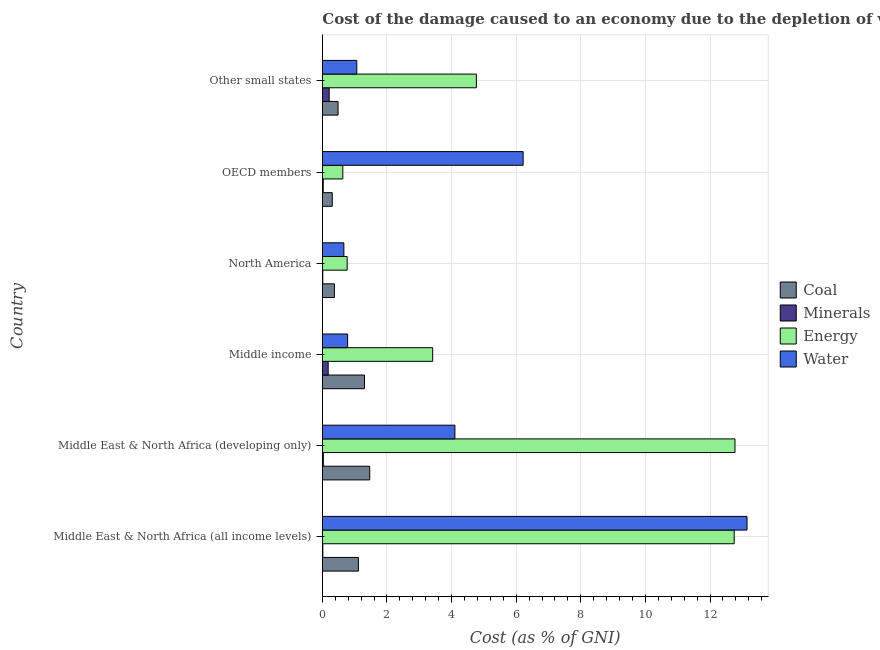How many different coloured bars are there?
Your response must be concise. 4. How many groups of bars are there?
Give a very brief answer. 6. Are the number of bars per tick equal to the number of legend labels?
Give a very brief answer. Yes. Are the number of bars on each tick of the Y-axis equal?
Offer a very short reply. Yes. How many bars are there on the 6th tick from the top?
Keep it short and to the point. 4. How many bars are there on the 3rd tick from the bottom?
Your answer should be compact. 4. What is the label of the 1st group of bars from the top?
Make the answer very short. Other small states. What is the cost of damage due to depletion of minerals in Other small states?
Make the answer very short. 0.21. Across all countries, what is the maximum cost of damage due to depletion of coal?
Your answer should be very brief. 1.47. Across all countries, what is the minimum cost of damage due to depletion of water?
Your response must be concise. 0.67. In which country was the cost of damage due to depletion of minerals maximum?
Your response must be concise. Other small states. What is the total cost of damage due to depletion of minerals in the graph?
Your response must be concise. 0.48. What is the difference between the cost of damage due to depletion of water in Middle income and that in OECD members?
Keep it short and to the point. -5.43. What is the difference between the cost of damage due to depletion of energy in OECD members and the cost of damage due to depletion of water in Middle East & North Africa (all income levels)?
Your answer should be very brief. -12.51. What is the average cost of damage due to depletion of coal per country?
Provide a succinct answer. 0.84. What is the difference between the cost of damage due to depletion of energy and cost of damage due to depletion of water in Middle East & North Africa (all income levels)?
Your answer should be very brief. -0.4. In how many countries, is the cost of damage due to depletion of water greater than 7.6 %?
Your answer should be very brief. 1. What is the ratio of the cost of damage due to depletion of minerals in Middle income to that in North America?
Ensure brevity in your answer.  12.58. Is the difference between the cost of damage due to depletion of water in Middle East & North Africa (developing only) and Other small states greater than the difference between the cost of damage due to depletion of coal in Middle East & North Africa (developing only) and Other small states?
Give a very brief answer. Yes. What is the difference between the highest and the second highest cost of damage due to depletion of coal?
Ensure brevity in your answer.  0.16. What is the difference between the highest and the lowest cost of damage due to depletion of coal?
Offer a terse response. 1.16. In how many countries, is the cost of damage due to depletion of coal greater than the average cost of damage due to depletion of coal taken over all countries?
Provide a succinct answer. 3. Is it the case that in every country, the sum of the cost of damage due to depletion of minerals and cost of damage due to depletion of water is greater than the sum of cost of damage due to depletion of coal and cost of damage due to depletion of energy?
Your response must be concise. No. What does the 1st bar from the top in OECD members represents?
Make the answer very short. Water. What does the 1st bar from the bottom in Middle East & North Africa (developing only) represents?
Provide a short and direct response. Coal. Is it the case that in every country, the sum of the cost of damage due to depletion of coal and cost of damage due to depletion of minerals is greater than the cost of damage due to depletion of energy?
Your answer should be very brief. No. How many countries are there in the graph?
Keep it short and to the point. 6. What is the difference between two consecutive major ticks on the X-axis?
Offer a terse response. 2. Does the graph contain any zero values?
Offer a terse response. No. What is the title of the graph?
Provide a short and direct response. Cost of the damage caused to an economy due to the depletion of various resources in 2003 . What is the label or title of the X-axis?
Your answer should be compact. Cost (as % of GNI). What is the label or title of the Y-axis?
Give a very brief answer. Country. What is the Cost (as % of GNI) of Coal in Middle East & North Africa (all income levels)?
Provide a succinct answer. 1.12. What is the Cost (as % of GNI) of Minerals in Middle East & North Africa (all income levels)?
Make the answer very short. 0.02. What is the Cost (as % of GNI) in Energy in Middle East & North Africa (all income levels)?
Offer a terse response. 12.75. What is the Cost (as % of GNI) in Water in Middle East & North Africa (all income levels)?
Your response must be concise. 13.15. What is the Cost (as % of GNI) in Coal in Middle East & North Africa (developing only)?
Your answer should be compact. 1.47. What is the Cost (as % of GNI) in Minerals in Middle East & North Africa (developing only)?
Give a very brief answer. 0.03. What is the Cost (as % of GNI) of Energy in Middle East & North Africa (developing only)?
Keep it short and to the point. 12.77. What is the Cost (as % of GNI) of Water in Middle East & North Africa (developing only)?
Make the answer very short. 4.1. What is the Cost (as % of GNI) in Coal in Middle income?
Make the answer very short. 1.31. What is the Cost (as % of GNI) in Minerals in Middle income?
Provide a succinct answer. 0.18. What is the Cost (as % of GNI) in Energy in Middle income?
Provide a succinct answer. 3.42. What is the Cost (as % of GNI) of Water in Middle income?
Offer a terse response. 0.78. What is the Cost (as % of GNI) of Coal in North America?
Make the answer very short. 0.37. What is the Cost (as % of GNI) of Minerals in North America?
Your answer should be very brief. 0.01. What is the Cost (as % of GNI) in Energy in North America?
Offer a terse response. 0.77. What is the Cost (as % of GNI) in Water in North America?
Give a very brief answer. 0.67. What is the Cost (as % of GNI) in Coal in OECD members?
Provide a short and direct response. 0.31. What is the Cost (as % of GNI) in Minerals in OECD members?
Provide a succinct answer. 0.03. What is the Cost (as % of GNI) of Energy in OECD members?
Your response must be concise. 0.63. What is the Cost (as % of GNI) of Water in OECD members?
Your answer should be compact. 6.22. What is the Cost (as % of GNI) in Coal in Other small states?
Ensure brevity in your answer.  0.49. What is the Cost (as % of GNI) of Minerals in Other small states?
Provide a succinct answer. 0.21. What is the Cost (as % of GNI) in Energy in Other small states?
Ensure brevity in your answer.  4.77. What is the Cost (as % of GNI) in Water in Other small states?
Your response must be concise. 1.07. Across all countries, what is the maximum Cost (as % of GNI) in Coal?
Provide a succinct answer. 1.47. Across all countries, what is the maximum Cost (as % of GNI) in Minerals?
Offer a terse response. 0.21. Across all countries, what is the maximum Cost (as % of GNI) in Energy?
Keep it short and to the point. 12.77. Across all countries, what is the maximum Cost (as % of GNI) of Water?
Your response must be concise. 13.15. Across all countries, what is the minimum Cost (as % of GNI) of Coal?
Provide a succinct answer. 0.31. Across all countries, what is the minimum Cost (as % of GNI) in Minerals?
Keep it short and to the point. 0.01. Across all countries, what is the minimum Cost (as % of GNI) of Energy?
Keep it short and to the point. 0.63. Across all countries, what is the minimum Cost (as % of GNI) of Water?
Make the answer very short. 0.67. What is the total Cost (as % of GNI) in Coal in the graph?
Give a very brief answer. 5.06. What is the total Cost (as % of GNI) of Minerals in the graph?
Provide a short and direct response. 0.48. What is the total Cost (as % of GNI) in Energy in the graph?
Your answer should be compact. 35.11. What is the total Cost (as % of GNI) in Water in the graph?
Offer a terse response. 25.98. What is the difference between the Cost (as % of GNI) in Coal in Middle East & North Africa (all income levels) and that in Middle East & North Africa (developing only)?
Ensure brevity in your answer.  -0.35. What is the difference between the Cost (as % of GNI) of Minerals in Middle East & North Africa (all income levels) and that in Middle East & North Africa (developing only)?
Offer a very short reply. -0.02. What is the difference between the Cost (as % of GNI) of Energy in Middle East & North Africa (all income levels) and that in Middle East & North Africa (developing only)?
Give a very brief answer. -0.02. What is the difference between the Cost (as % of GNI) in Water in Middle East & North Africa (all income levels) and that in Middle East & North Africa (developing only)?
Give a very brief answer. 9.04. What is the difference between the Cost (as % of GNI) of Coal in Middle East & North Africa (all income levels) and that in Middle income?
Make the answer very short. -0.19. What is the difference between the Cost (as % of GNI) in Minerals in Middle East & North Africa (all income levels) and that in Middle income?
Your answer should be compact. -0.17. What is the difference between the Cost (as % of GNI) of Energy in Middle East & North Africa (all income levels) and that in Middle income?
Your answer should be very brief. 9.33. What is the difference between the Cost (as % of GNI) of Water in Middle East & North Africa (all income levels) and that in Middle income?
Your response must be concise. 12.36. What is the difference between the Cost (as % of GNI) of Coal in Middle East & North Africa (all income levels) and that in North America?
Provide a succinct answer. 0.74. What is the difference between the Cost (as % of GNI) in Minerals in Middle East & North Africa (all income levels) and that in North America?
Provide a succinct answer. 0. What is the difference between the Cost (as % of GNI) in Energy in Middle East & North Africa (all income levels) and that in North America?
Your response must be concise. 11.98. What is the difference between the Cost (as % of GNI) in Water in Middle East & North Africa (all income levels) and that in North America?
Your answer should be compact. 12.48. What is the difference between the Cost (as % of GNI) of Coal in Middle East & North Africa (all income levels) and that in OECD members?
Give a very brief answer. 0.81. What is the difference between the Cost (as % of GNI) of Minerals in Middle East & North Africa (all income levels) and that in OECD members?
Your answer should be compact. -0.01. What is the difference between the Cost (as % of GNI) of Energy in Middle East & North Africa (all income levels) and that in OECD members?
Keep it short and to the point. 12.11. What is the difference between the Cost (as % of GNI) in Water in Middle East & North Africa (all income levels) and that in OECD members?
Provide a short and direct response. 6.93. What is the difference between the Cost (as % of GNI) in Coal in Middle East & North Africa (all income levels) and that in Other small states?
Keep it short and to the point. 0.63. What is the difference between the Cost (as % of GNI) in Minerals in Middle East & North Africa (all income levels) and that in Other small states?
Ensure brevity in your answer.  -0.2. What is the difference between the Cost (as % of GNI) in Energy in Middle East & North Africa (all income levels) and that in Other small states?
Ensure brevity in your answer.  7.98. What is the difference between the Cost (as % of GNI) in Water in Middle East & North Africa (all income levels) and that in Other small states?
Your answer should be very brief. 12.08. What is the difference between the Cost (as % of GNI) in Coal in Middle East & North Africa (developing only) and that in Middle income?
Your answer should be compact. 0.16. What is the difference between the Cost (as % of GNI) of Minerals in Middle East & North Africa (developing only) and that in Middle income?
Your answer should be very brief. -0.15. What is the difference between the Cost (as % of GNI) in Energy in Middle East & North Africa (developing only) and that in Middle income?
Make the answer very short. 9.36. What is the difference between the Cost (as % of GNI) in Water in Middle East & North Africa (developing only) and that in Middle income?
Provide a short and direct response. 3.32. What is the difference between the Cost (as % of GNI) of Coal in Middle East & North Africa (developing only) and that in North America?
Provide a short and direct response. 1.09. What is the difference between the Cost (as % of GNI) of Minerals in Middle East & North Africa (developing only) and that in North America?
Give a very brief answer. 0.02. What is the difference between the Cost (as % of GNI) in Energy in Middle East & North Africa (developing only) and that in North America?
Make the answer very short. 12. What is the difference between the Cost (as % of GNI) in Water in Middle East & North Africa (developing only) and that in North America?
Offer a very short reply. 3.44. What is the difference between the Cost (as % of GNI) of Coal in Middle East & North Africa (developing only) and that in OECD members?
Provide a short and direct response. 1.16. What is the difference between the Cost (as % of GNI) in Minerals in Middle East & North Africa (developing only) and that in OECD members?
Your response must be concise. 0. What is the difference between the Cost (as % of GNI) in Energy in Middle East & North Africa (developing only) and that in OECD members?
Ensure brevity in your answer.  12.14. What is the difference between the Cost (as % of GNI) in Water in Middle East & North Africa (developing only) and that in OECD members?
Give a very brief answer. -2.11. What is the difference between the Cost (as % of GNI) of Coal in Middle East & North Africa (developing only) and that in Other small states?
Your answer should be very brief. 0.98. What is the difference between the Cost (as % of GNI) of Minerals in Middle East & North Africa (developing only) and that in Other small states?
Ensure brevity in your answer.  -0.18. What is the difference between the Cost (as % of GNI) of Energy in Middle East & North Africa (developing only) and that in Other small states?
Offer a terse response. 8.01. What is the difference between the Cost (as % of GNI) in Water in Middle East & North Africa (developing only) and that in Other small states?
Your answer should be compact. 3.04. What is the difference between the Cost (as % of GNI) of Coal in Middle income and that in North America?
Your response must be concise. 0.93. What is the difference between the Cost (as % of GNI) of Minerals in Middle income and that in North America?
Provide a succinct answer. 0.17. What is the difference between the Cost (as % of GNI) in Energy in Middle income and that in North America?
Give a very brief answer. 2.65. What is the difference between the Cost (as % of GNI) of Water in Middle income and that in North America?
Offer a very short reply. 0.12. What is the difference between the Cost (as % of GNI) in Minerals in Middle income and that in OECD members?
Your answer should be compact. 0.15. What is the difference between the Cost (as % of GNI) in Energy in Middle income and that in OECD members?
Make the answer very short. 2.78. What is the difference between the Cost (as % of GNI) in Water in Middle income and that in OECD members?
Your answer should be compact. -5.43. What is the difference between the Cost (as % of GNI) in Coal in Middle income and that in Other small states?
Offer a very short reply. 0.82. What is the difference between the Cost (as % of GNI) in Minerals in Middle income and that in Other small states?
Ensure brevity in your answer.  -0.03. What is the difference between the Cost (as % of GNI) in Energy in Middle income and that in Other small states?
Make the answer very short. -1.35. What is the difference between the Cost (as % of GNI) of Water in Middle income and that in Other small states?
Your answer should be very brief. -0.28. What is the difference between the Cost (as % of GNI) in Coal in North America and that in OECD members?
Offer a terse response. 0.07. What is the difference between the Cost (as % of GNI) in Minerals in North America and that in OECD members?
Make the answer very short. -0.01. What is the difference between the Cost (as % of GNI) of Energy in North America and that in OECD members?
Provide a succinct answer. 0.13. What is the difference between the Cost (as % of GNI) in Water in North America and that in OECD members?
Make the answer very short. -5.55. What is the difference between the Cost (as % of GNI) of Coal in North America and that in Other small states?
Your answer should be compact. -0.11. What is the difference between the Cost (as % of GNI) in Minerals in North America and that in Other small states?
Offer a very short reply. -0.2. What is the difference between the Cost (as % of GNI) in Energy in North America and that in Other small states?
Offer a terse response. -4. What is the difference between the Cost (as % of GNI) in Water in North America and that in Other small states?
Give a very brief answer. -0.4. What is the difference between the Cost (as % of GNI) of Coal in OECD members and that in Other small states?
Provide a short and direct response. -0.18. What is the difference between the Cost (as % of GNI) in Minerals in OECD members and that in Other small states?
Make the answer very short. -0.18. What is the difference between the Cost (as % of GNI) in Energy in OECD members and that in Other small states?
Your answer should be very brief. -4.13. What is the difference between the Cost (as % of GNI) in Water in OECD members and that in Other small states?
Your answer should be very brief. 5.15. What is the difference between the Cost (as % of GNI) of Coal in Middle East & North Africa (all income levels) and the Cost (as % of GNI) of Minerals in Middle East & North Africa (developing only)?
Provide a succinct answer. 1.09. What is the difference between the Cost (as % of GNI) in Coal in Middle East & North Africa (all income levels) and the Cost (as % of GNI) in Energy in Middle East & North Africa (developing only)?
Your response must be concise. -11.66. What is the difference between the Cost (as % of GNI) of Coal in Middle East & North Africa (all income levels) and the Cost (as % of GNI) of Water in Middle East & North Africa (developing only)?
Provide a succinct answer. -2.99. What is the difference between the Cost (as % of GNI) in Minerals in Middle East & North Africa (all income levels) and the Cost (as % of GNI) in Energy in Middle East & North Africa (developing only)?
Offer a very short reply. -12.76. What is the difference between the Cost (as % of GNI) of Minerals in Middle East & North Africa (all income levels) and the Cost (as % of GNI) of Water in Middle East & North Africa (developing only)?
Provide a short and direct response. -4.09. What is the difference between the Cost (as % of GNI) in Energy in Middle East & North Africa (all income levels) and the Cost (as % of GNI) in Water in Middle East & North Africa (developing only)?
Keep it short and to the point. 8.65. What is the difference between the Cost (as % of GNI) of Coal in Middle East & North Africa (all income levels) and the Cost (as % of GNI) of Minerals in Middle income?
Your answer should be compact. 0.94. What is the difference between the Cost (as % of GNI) of Coal in Middle East & North Africa (all income levels) and the Cost (as % of GNI) of Energy in Middle income?
Keep it short and to the point. -2.3. What is the difference between the Cost (as % of GNI) of Coal in Middle East & North Africa (all income levels) and the Cost (as % of GNI) of Water in Middle income?
Provide a short and direct response. 0.33. What is the difference between the Cost (as % of GNI) of Minerals in Middle East & North Africa (all income levels) and the Cost (as % of GNI) of Energy in Middle income?
Provide a succinct answer. -3.4. What is the difference between the Cost (as % of GNI) in Minerals in Middle East & North Africa (all income levels) and the Cost (as % of GNI) in Water in Middle income?
Give a very brief answer. -0.77. What is the difference between the Cost (as % of GNI) in Energy in Middle East & North Africa (all income levels) and the Cost (as % of GNI) in Water in Middle income?
Ensure brevity in your answer.  11.97. What is the difference between the Cost (as % of GNI) of Coal in Middle East & North Africa (all income levels) and the Cost (as % of GNI) of Minerals in North America?
Keep it short and to the point. 1.1. What is the difference between the Cost (as % of GNI) of Coal in Middle East & North Africa (all income levels) and the Cost (as % of GNI) of Energy in North America?
Offer a very short reply. 0.35. What is the difference between the Cost (as % of GNI) of Coal in Middle East & North Africa (all income levels) and the Cost (as % of GNI) of Water in North America?
Keep it short and to the point. 0.45. What is the difference between the Cost (as % of GNI) of Minerals in Middle East & North Africa (all income levels) and the Cost (as % of GNI) of Energy in North America?
Your response must be concise. -0.75. What is the difference between the Cost (as % of GNI) in Minerals in Middle East & North Africa (all income levels) and the Cost (as % of GNI) in Water in North America?
Keep it short and to the point. -0.65. What is the difference between the Cost (as % of GNI) in Energy in Middle East & North Africa (all income levels) and the Cost (as % of GNI) in Water in North America?
Your answer should be very brief. 12.08. What is the difference between the Cost (as % of GNI) of Coal in Middle East & North Africa (all income levels) and the Cost (as % of GNI) of Minerals in OECD members?
Keep it short and to the point. 1.09. What is the difference between the Cost (as % of GNI) of Coal in Middle East & North Africa (all income levels) and the Cost (as % of GNI) of Energy in OECD members?
Your answer should be compact. 0.48. What is the difference between the Cost (as % of GNI) in Coal in Middle East & North Africa (all income levels) and the Cost (as % of GNI) in Water in OECD members?
Your response must be concise. -5.1. What is the difference between the Cost (as % of GNI) in Minerals in Middle East & North Africa (all income levels) and the Cost (as % of GNI) in Energy in OECD members?
Make the answer very short. -0.62. What is the difference between the Cost (as % of GNI) in Minerals in Middle East & North Africa (all income levels) and the Cost (as % of GNI) in Water in OECD members?
Your answer should be compact. -6.2. What is the difference between the Cost (as % of GNI) in Energy in Middle East & North Africa (all income levels) and the Cost (as % of GNI) in Water in OECD members?
Offer a terse response. 6.53. What is the difference between the Cost (as % of GNI) of Coal in Middle East & North Africa (all income levels) and the Cost (as % of GNI) of Minerals in Other small states?
Offer a terse response. 0.91. What is the difference between the Cost (as % of GNI) of Coal in Middle East & North Africa (all income levels) and the Cost (as % of GNI) of Energy in Other small states?
Provide a short and direct response. -3.65. What is the difference between the Cost (as % of GNI) of Coal in Middle East & North Africa (all income levels) and the Cost (as % of GNI) of Water in Other small states?
Offer a terse response. 0.05. What is the difference between the Cost (as % of GNI) of Minerals in Middle East & North Africa (all income levels) and the Cost (as % of GNI) of Energy in Other small states?
Your answer should be very brief. -4.75. What is the difference between the Cost (as % of GNI) of Minerals in Middle East & North Africa (all income levels) and the Cost (as % of GNI) of Water in Other small states?
Provide a succinct answer. -1.05. What is the difference between the Cost (as % of GNI) in Energy in Middle East & North Africa (all income levels) and the Cost (as % of GNI) in Water in Other small states?
Provide a succinct answer. 11.68. What is the difference between the Cost (as % of GNI) in Coal in Middle East & North Africa (developing only) and the Cost (as % of GNI) in Minerals in Middle income?
Offer a very short reply. 1.28. What is the difference between the Cost (as % of GNI) of Coal in Middle East & North Africa (developing only) and the Cost (as % of GNI) of Energy in Middle income?
Your answer should be very brief. -1.95. What is the difference between the Cost (as % of GNI) of Coal in Middle East & North Africa (developing only) and the Cost (as % of GNI) of Water in Middle income?
Provide a short and direct response. 0.68. What is the difference between the Cost (as % of GNI) of Minerals in Middle East & North Africa (developing only) and the Cost (as % of GNI) of Energy in Middle income?
Provide a short and direct response. -3.39. What is the difference between the Cost (as % of GNI) of Minerals in Middle East & North Africa (developing only) and the Cost (as % of GNI) of Water in Middle income?
Provide a succinct answer. -0.75. What is the difference between the Cost (as % of GNI) of Energy in Middle East & North Africa (developing only) and the Cost (as % of GNI) of Water in Middle income?
Provide a succinct answer. 11.99. What is the difference between the Cost (as % of GNI) of Coal in Middle East & North Africa (developing only) and the Cost (as % of GNI) of Minerals in North America?
Your answer should be very brief. 1.45. What is the difference between the Cost (as % of GNI) of Coal in Middle East & North Africa (developing only) and the Cost (as % of GNI) of Energy in North America?
Ensure brevity in your answer.  0.7. What is the difference between the Cost (as % of GNI) in Coal in Middle East & North Africa (developing only) and the Cost (as % of GNI) in Water in North America?
Your answer should be compact. 0.8. What is the difference between the Cost (as % of GNI) of Minerals in Middle East & North Africa (developing only) and the Cost (as % of GNI) of Energy in North America?
Provide a succinct answer. -0.74. What is the difference between the Cost (as % of GNI) of Minerals in Middle East & North Africa (developing only) and the Cost (as % of GNI) of Water in North America?
Your answer should be very brief. -0.64. What is the difference between the Cost (as % of GNI) in Energy in Middle East & North Africa (developing only) and the Cost (as % of GNI) in Water in North America?
Your answer should be compact. 12.11. What is the difference between the Cost (as % of GNI) of Coal in Middle East & North Africa (developing only) and the Cost (as % of GNI) of Minerals in OECD members?
Keep it short and to the point. 1.44. What is the difference between the Cost (as % of GNI) of Coal in Middle East & North Africa (developing only) and the Cost (as % of GNI) of Energy in OECD members?
Ensure brevity in your answer.  0.83. What is the difference between the Cost (as % of GNI) of Coal in Middle East & North Africa (developing only) and the Cost (as % of GNI) of Water in OECD members?
Your answer should be compact. -4.75. What is the difference between the Cost (as % of GNI) in Minerals in Middle East & North Africa (developing only) and the Cost (as % of GNI) in Energy in OECD members?
Give a very brief answer. -0.6. What is the difference between the Cost (as % of GNI) in Minerals in Middle East & North Africa (developing only) and the Cost (as % of GNI) in Water in OECD members?
Offer a very short reply. -6.18. What is the difference between the Cost (as % of GNI) in Energy in Middle East & North Africa (developing only) and the Cost (as % of GNI) in Water in OECD members?
Keep it short and to the point. 6.56. What is the difference between the Cost (as % of GNI) of Coal in Middle East & North Africa (developing only) and the Cost (as % of GNI) of Minerals in Other small states?
Your answer should be compact. 1.25. What is the difference between the Cost (as % of GNI) in Coal in Middle East & North Africa (developing only) and the Cost (as % of GNI) in Energy in Other small states?
Give a very brief answer. -3.3. What is the difference between the Cost (as % of GNI) of Coal in Middle East & North Africa (developing only) and the Cost (as % of GNI) of Water in Other small states?
Make the answer very short. 0.4. What is the difference between the Cost (as % of GNI) of Minerals in Middle East & North Africa (developing only) and the Cost (as % of GNI) of Energy in Other small states?
Offer a terse response. -4.74. What is the difference between the Cost (as % of GNI) in Minerals in Middle East & North Africa (developing only) and the Cost (as % of GNI) in Water in Other small states?
Make the answer very short. -1.04. What is the difference between the Cost (as % of GNI) in Energy in Middle East & North Africa (developing only) and the Cost (as % of GNI) in Water in Other small states?
Provide a short and direct response. 11.71. What is the difference between the Cost (as % of GNI) of Coal in Middle income and the Cost (as % of GNI) of Minerals in North America?
Give a very brief answer. 1.29. What is the difference between the Cost (as % of GNI) in Coal in Middle income and the Cost (as % of GNI) in Energy in North America?
Offer a terse response. 0.54. What is the difference between the Cost (as % of GNI) in Coal in Middle income and the Cost (as % of GNI) in Water in North America?
Provide a short and direct response. 0.64. What is the difference between the Cost (as % of GNI) of Minerals in Middle income and the Cost (as % of GNI) of Energy in North America?
Your response must be concise. -0.59. What is the difference between the Cost (as % of GNI) of Minerals in Middle income and the Cost (as % of GNI) of Water in North America?
Offer a terse response. -0.49. What is the difference between the Cost (as % of GNI) in Energy in Middle income and the Cost (as % of GNI) in Water in North America?
Make the answer very short. 2.75. What is the difference between the Cost (as % of GNI) of Coal in Middle income and the Cost (as % of GNI) of Minerals in OECD members?
Offer a very short reply. 1.28. What is the difference between the Cost (as % of GNI) in Coal in Middle income and the Cost (as % of GNI) in Energy in OECD members?
Offer a very short reply. 0.67. What is the difference between the Cost (as % of GNI) in Coal in Middle income and the Cost (as % of GNI) in Water in OECD members?
Your answer should be compact. -4.91. What is the difference between the Cost (as % of GNI) of Minerals in Middle income and the Cost (as % of GNI) of Energy in OECD members?
Your answer should be compact. -0.45. What is the difference between the Cost (as % of GNI) in Minerals in Middle income and the Cost (as % of GNI) in Water in OECD members?
Your response must be concise. -6.03. What is the difference between the Cost (as % of GNI) of Energy in Middle income and the Cost (as % of GNI) of Water in OECD members?
Your answer should be compact. -2.8. What is the difference between the Cost (as % of GNI) in Coal in Middle income and the Cost (as % of GNI) in Minerals in Other small states?
Offer a very short reply. 1.09. What is the difference between the Cost (as % of GNI) of Coal in Middle income and the Cost (as % of GNI) of Energy in Other small states?
Offer a very short reply. -3.46. What is the difference between the Cost (as % of GNI) in Coal in Middle income and the Cost (as % of GNI) in Water in Other small states?
Your response must be concise. 0.24. What is the difference between the Cost (as % of GNI) in Minerals in Middle income and the Cost (as % of GNI) in Energy in Other small states?
Your response must be concise. -4.59. What is the difference between the Cost (as % of GNI) of Minerals in Middle income and the Cost (as % of GNI) of Water in Other small states?
Your response must be concise. -0.89. What is the difference between the Cost (as % of GNI) in Energy in Middle income and the Cost (as % of GNI) in Water in Other small states?
Offer a terse response. 2.35. What is the difference between the Cost (as % of GNI) in Coal in North America and the Cost (as % of GNI) in Minerals in OECD members?
Make the answer very short. 0.35. What is the difference between the Cost (as % of GNI) in Coal in North America and the Cost (as % of GNI) in Energy in OECD members?
Your answer should be compact. -0.26. What is the difference between the Cost (as % of GNI) of Coal in North America and the Cost (as % of GNI) of Water in OECD members?
Offer a very short reply. -5.84. What is the difference between the Cost (as % of GNI) of Minerals in North America and the Cost (as % of GNI) of Energy in OECD members?
Provide a short and direct response. -0.62. What is the difference between the Cost (as % of GNI) of Minerals in North America and the Cost (as % of GNI) of Water in OECD members?
Give a very brief answer. -6.2. What is the difference between the Cost (as % of GNI) of Energy in North America and the Cost (as % of GNI) of Water in OECD members?
Your response must be concise. -5.45. What is the difference between the Cost (as % of GNI) of Coal in North America and the Cost (as % of GNI) of Minerals in Other small states?
Your answer should be very brief. 0.16. What is the difference between the Cost (as % of GNI) in Coal in North America and the Cost (as % of GNI) in Energy in Other small states?
Give a very brief answer. -4.39. What is the difference between the Cost (as % of GNI) of Coal in North America and the Cost (as % of GNI) of Water in Other small states?
Your answer should be compact. -0.69. What is the difference between the Cost (as % of GNI) in Minerals in North America and the Cost (as % of GNI) in Energy in Other small states?
Provide a succinct answer. -4.75. What is the difference between the Cost (as % of GNI) of Minerals in North America and the Cost (as % of GNI) of Water in Other small states?
Provide a short and direct response. -1.05. What is the difference between the Cost (as % of GNI) of Energy in North America and the Cost (as % of GNI) of Water in Other small states?
Provide a short and direct response. -0.3. What is the difference between the Cost (as % of GNI) of Coal in OECD members and the Cost (as % of GNI) of Minerals in Other small states?
Your response must be concise. 0.1. What is the difference between the Cost (as % of GNI) of Coal in OECD members and the Cost (as % of GNI) of Energy in Other small states?
Offer a terse response. -4.46. What is the difference between the Cost (as % of GNI) of Coal in OECD members and the Cost (as % of GNI) of Water in Other small states?
Provide a short and direct response. -0.76. What is the difference between the Cost (as % of GNI) in Minerals in OECD members and the Cost (as % of GNI) in Energy in Other small states?
Provide a short and direct response. -4.74. What is the difference between the Cost (as % of GNI) of Minerals in OECD members and the Cost (as % of GNI) of Water in Other small states?
Provide a short and direct response. -1.04. What is the difference between the Cost (as % of GNI) of Energy in OECD members and the Cost (as % of GNI) of Water in Other small states?
Your response must be concise. -0.43. What is the average Cost (as % of GNI) in Coal per country?
Provide a succinct answer. 0.84. What is the average Cost (as % of GNI) of Minerals per country?
Provide a short and direct response. 0.08. What is the average Cost (as % of GNI) in Energy per country?
Your answer should be very brief. 5.85. What is the average Cost (as % of GNI) of Water per country?
Provide a succinct answer. 4.33. What is the difference between the Cost (as % of GNI) of Coal and Cost (as % of GNI) of Minerals in Middle East & North Africa (all income levels)?
Offer a terse response. 1.1. What is the difference between the Cost (as % of GNI) of Coal and Cost (as % of GNI) of Energy in Middle East & North Africa (all income levels)?
Provide a succinct answer. -11.63. What is the difference between the Cost (as % of GNI) in Coal and Cost (as % of GNI) in Water in Middle East & North Africa (all income levels)?
Give a very brief answer. -12.03. What is the difference between the Cost (as % of GNI) in Minerals and Cost (as % of GNI) in Energy in Middle East & North Africa (all income levels)?
Make the answer very short. -12.73. What is the difference between the Cost (as % of GNI) of Minerals and Cost (as % of GNI) of Water in Middle East & North Africa (all income levels)?
Make the answer very short. -13.13. What is the difference between the Cost (as % of GNI) of Energy and Cost (as % of GNI) of Water in Middle East & North Africa (all income levels)?
Provide a succinct answer. -0.4. What is the difference between the Cost (as % of GNI) in Coal and Cost (as % of GNI) in Minerals in Middle East & North Africa (developing only)?
Offer a very short reply. 1.44. What is the difference between the Cost (as % of GNI) of Coal and Cost (as % of GNI) of Energy in Middle East & North Africa (developing only)?
Offer a very short reply. -11.31. What is the difference between the Cost (as % of GNI) in Coal and Cost (as % of GNI) in Water in Middle East & North Africa (developing only)?
Provide a succinct answer. -2.64. What is the difference between the Cost (as % of GNI) in Minerals and Cost (as % of GNI) in Energy in Middle East & North Africa (developing only)?
Offer a terse response. -12.74. What is the difference between the Cost (as % of GNI) in Minerals and Cost (as % of GNI) in Water in Middle East & North Africa (developing only)?
Ensure brevity in your answer.  -4.07. What is the difference between the Cost (as % of GNI) of Energy and Cost (as % of GNI) of Water in Middle East & North Africa (developing only)?
Give a very brief answer. 8.67. What is the difference between the Cost (as % of GNI) of Coal and Cost (as % of GNI) of Minerals in Middle income?
Give a very brief answer. 1.12. What is the difference between the Cost (as % of GNI) of Coal and Cost (as % of GNI) of Energy in Middle income?
Make the answer very short. -2.11. What is the difference between the Cost (as % of GNI) in Coal and Cost (as % of GNI) in Water in Middle income?
Provide a short and direct response. 0.52. What is the difference between the Cost (as % of GNI) of Minerals and Cost (as % of GNI) of Energy in Middle income?
Offer a terse response. -3.23. What is the difference between the Cost (as % of GNI) in Minerals and Cost (as % of GNI) in Water in Middle income?
Your answer should be compact. -0.6. What is the difference between the Cost (as % of GNI) of Energy and Cost (as % of GNI) of Water in Middle income?
Make the answer very short. 2.63. What is the difference between the Cost (as % of GNI) of Coal and Cost (as % of GNI) of Minerals in North America?
Offer a terse response. 0.36. What is the difference between the Cost (as % of GNI) in Coal and Cost (as % of GNI) in Energy in North America?
Offer a terse response. -0.4. What is the difference between the Cost (as % of GNI) of Coal and Cost (as % of GNI) of Water in North America?
Your response must be concise. -0.29. What is the difference between the Cost (as % of GNI) in Minerals and Cost (as % of GNI) in Energy in North America?
Provide a succinct answer. -0.75. What is the difference between the Cost (as % of GNI) of Minerals and Cost (as % of GNI) of Water in North America?
Keep it short and to the point. -0.65. What is the difference between the Cost (as % of GNI) in Energy and Cost (as % of GNI) in Water in North America?
Offer a terse response. 0.1. What is the difference between the Cost (as % of GNI) in Coal and Cost (as % of GNI) in Minerals in OECD members?
Provide a succinct answer. 0.28. What is the difference between the Cost (as % of GNI) of Coal and Cost (as % of GNI) of Energy in OECD members?
Make the answer very short. -0.33. What is the difference between the Cost (as % of GNI) of Coal and Cost (as % of GNI) of Water in OECD members?
Give a very brief answer. -5.91. What is the difference between the Cost (as % of GNI) in Minerals and Cost (as % of GNI) in Energy in OECD members?
Provide a succinct answer. -0.61. What is the difference between the Cost (as % of GNI) in Minerals and Cost (as % of GNI) in Water in OECD members?
Offer a very short reply. -6.19. What is the difference between the Cost (as % of GNI) of Energy and Cost (as % of GNI) of Water in OECD members?
Offer a very short reply. -5.58. What is the difference between the Cost (as % of GNI) of Coal and Cost (as % of GNI) of Minerals in Other small states?
Provide a short and direct response. 0.27. What is the difference between the Cost (as % of GNI) in Coal and Cost (as % of GNI) in Energy in Other small states?
Offer a very short reply. -4.28. What is the difference between the Cost (as % of GNI) of Coal and Cost (as % of GNI) of Water in Other small states?
Give a very brief answer. -0.58. What is the difference between the Cost (as % of GNI) in Minerals and Cost (as % of GNI) in Energy in Other small states?
Ensure brevity in your answer.  -4.56. What is the difference between the Cost (as % of GNI) of Minerals and Cost (as % of GNI) of Water in Other small states?
Your answer should be compact. -0.85. What is the difference between the Cost (as % of GNI) in Energy and Cost (as % of GNI) in Water in Other small states?
Your answer should be compact. 3.7. What is the ratio of the Cost (as % of GNI) in Coal in Middle East & North Africa (all income levels) to that in Middle East & North Africa (developing only)?
Offer a terse response. 0.76. What is the ratio of the Cost (as % of GNI) of Minerals in Middle East & North Africa (all income levels) to that in Middle East & North Africa (developing only)?
Ensure brevity in your answer.  0.51. What is the ratio of the Cost (as % of GNI) in Water in Middle East & North Africa (all income levels) to that in Middle East & North Africa (developing only)?
Your answer should be compact. 3.2. What is the ratio of the Cost (as % of GNI) of Coal in Middle East & North Africa (all income levels) to that in Middle income?
Offer a very short reply. 0.86. What is the ratio of the Cost (as % of GNI) in Minerals in Middle East & North Africa (all income levels) to that in Middle income?
Offer a terse response. 0.09. What is the ratio of the Cost (as % of GNI) of Energy in Middle East & North Africa (all income levels) to that in Middle income?
Provide a succinct answer. 3.73. What is the ratio of the Cost (as % of GNI) of Water in Middle East & North Africa (all income levels) to that in Middle income?
Offer a very short reply. 16.78. What is the ratio of the Cost (as % of GNI) in Coal in Middle East & North Africa (all income levels) to that in North America?
Your answer should be compact. 2.99. What is the ratio of the Cost (as % of GNI) of Minerals in Middle East & North Africa (all income levels) to that in North America?
Offer a very short reply. 1.09. What is the ratio of the Cost (as % of GNI) of Energy in Middle East & North Africa (all income levels) to that in North America?
Your answer should be compact. 16.58. What is the ratio of the Cost (as % of GNI) of Water in Middle East & North Africa (all income levels) to that in North America?
Keep it short and to the point. 19.71. What is the ratio of the Cost (as % of GNI) of Coal in Middle East & North Africa (all income levels) to that in OECD members?
Your answer should be very brief. 3.63. What is the ratio of the Cost (as % of GNI) in Minerals in Middle East & North Africa (all income levels) to that in OECD members?
Provide a short and direct response. 0.56. What is the ratio of the Cost (as % of GNI) of Energy in Middle East & North Africa (all income levels) to that in OECD members?
Ensure brevity in your answer.  20.1. What is the ratio of the Cost (as % of GNI) in Water in Middle East & North Africa (all income levels) to that in OECD members?
Make the answer very short. 2.11. What is the ratio of the Cost (as % of GNI) in Coal in Middle East & North Africa (all income levels) to that in Other small states?
Make the answer very short. 2.29. What is the ratio of the Cost (as % of GNI) of Minerals in Middle East & North Africa (all income levels) to that in Other small states?
Offer a very short reply. 0.07. What is the ratio of the Cost (as % of GNI) in Energy in Middle East & North Africa (all income levels) to that in Other small states?
Provide a succinct answer. 2.67. What is the ratio of the Cost (as % of GNI) of Water in Middle East & North Africa (all income levels) to that in Other small states?
Your answer should be compact. 12.32. What is the ratio of the Cost (as % of GNI) of Coal in Middle East & North Africa (developing only) to that in Middle income?
Your response must be concise. 1.12. What is the ratio of the Cost (as % of GNI) of Minerals in Middle East & North Africa (developing only) to that in Middle income?
Keep it short and to the point. 0.17. What is the ratio of the Cost (as % of GNI) of Energy in Middle East & North Africa (developing only) to that in Middle income?
Your response must be concise. 3.74. What is the ratio of the Cost (as % of GNI) in Water in Middle East & North Africa (developing only) to that in Middle income?
Ensure brevity in your answer.  5.24. What is the ratio of the Cost (as % of GNI) of Coal in Middle East & North Africa (developing only) to that in North America?
Provide a succinct answer. 3.92. What is the ratio of the Cost (as % of GNI) of Minerals in Middle East & North Africa (developing only) to that in North America?
Ensure brevity in your answer.  2.15. What is the ratio of the Cost (as % of GNI) of Energy in Middle East & North Africa (developing only) to that in North America?
Offer a very short reply. 16.61. What is the ratio of the Cost (as % of GNI) of Water in Middle East & North Africa (developing only) to that in North America?
Give a very brief answer. 6.15. What is the ratio of the Cost (as % of GNI) of Coal in Middle East & North Africa (developing only) to that in OECD members?
Offer a very short reply. 4.77. What is the ratio of the Cost (as % of GNI) of Energy in Middle East & North Africa (developing only) to that in OECD members?
Your response must be concise. 20.14. What is the ratio of the Cost (as % of GNI) in Water in Middle East & North Africa (developing only) to that in OECD members?
Your answer should be compact. 0.66. What is the ratio of the Cost (as % of GNI) of Coal in Middle East & North Africa (developing only) to that in Other small states?
Your response must be concise. 3.01. What is the ratio of the Cost (as % of GNI) of Minerals in Middle East & North Africa (developing only) to that in Other small states?
Keep it short and to the point. 0.15. What is the ratio of the Cost (as % of GNI) of Energy in Middle East & North Africa (developing only) to that in Other small states?
Offer a very short reply. 2.68. What is the ratio of the Cost (as % of GNI) of Water in Middle East & North Africa (developing only) to that in Other small states?
Your response must be concise. 3.85. What is the ratio of the Cost (as % of GNI) of Coal in Middle income to that in North America?
Offer a terse response. 3.49. What is the ratio of the Cost (as % of GNI) in Minerals in Middle income to that in North America?
Provide a succinct answer. 12.58. What is the ratio of the Cost (as % of GNI) in Energy in Middle income to that in North America?
Ensure brevity in your answer.  4.44. What is the ratio of the Cost (as % of GNI) in Water in Middle income to that in North America?
Keep it short and to the point. 1.17. What is the ratio of the Cost (as % of GNI) of Coal in Middle income to that in OECD members?
Your answer should be very brief. 4.25. What is the ratio of the Cost (as % of GNI) of Minerals in Middle income to that in OECD members?
Your answer should be very brief. 6.44. What is the ratio of the Cost (as % of GNI) in Energy in Middle income to that in OECD members?
Make the answer very short. 5.39. What is the ratio of the Cost (as % of GNI) of Water in Middle income to that in OECD members?
Provide a short and direct response. 0.13. What is the ratio of the Cost (as % of GNI) of Coal in Middle income to that in Other small states?
Provide a short and direct response. 2.68. What is the ratio of the Cost (as % of GNI) of Minerals in Middle income to that in Other small states?
Your answer should be very brief. 0.86. What is the ratio of the Cost (as % of GNI) of Energy in Middle income to that in Other small states?
Give a very brief answer. 0.72. What is the ratio of the Cost (as % of GNI) of Water in Middle income to that in Other small states?
Give a very brief answer. 0.73. What is the ratio of the Cost (as % of GNI) of Coal in North America to that in OECD members?
Keep it short and to the point. 1.22. What is the ratio of the Cost (as % of GNI) of Minerals in North America to that in OECD members?
Your answer should be very brief. 0.51. What is the ratio of the Cost (as % of GNI) in Energy in North America to that in OECD members?
Make the answer very short. 1.21. What is the ratio of the Cost (as % of GNI) of Water in North America to that in OECD members?
Make the answer very short. 0.11. What is the ratio of the Cost (as % of GNI) of Coal in North America to that in Other small states?
Offer a terse response. 0.77. What is the ratio of the Cost (as % of GNI) of Minerals in North America to that in Other small states?
Offer a terse response. 0.07. What is the ratio of the Cost (as % of GNI) of Energy in North America to that in Other small states?
Give a very brief answer. 0.16. What is the ratio of the Cost (as % of GNI) of Water in North America to that in Other small states?
Give a very brief answer. 0.62. What is the ratio of the Cost (as % of GNI) in Coal in OECD members to that in Other small states?
Keep it short and to the point. 0.63. What is the ratio of the Cost (as % of GNI) in Minerals in OECD members to that in Other small states?
Give a very brief answer. 0.13. What is the ratio of the Cost (as % of GNI) of Energy in OECD members to that in Other small states?
Give a very brief answer. 0.13. What is the ratio of the Cost (as % of GNI) of Water in OECD members to that in Other small states?
Your response must be concise. 5.83. What is the difference between the highest and the second highest Cost (as % of GNI) of Coal?
Your answer should be very brief. 0.16. What is the difference between the highest and the second highest Cost (as % of GNI) of Minerals?
Offer a very short reply. 0.03. What is the difference between the highest and the second highest Cost (as % of GNI) of Energy?
Make the answer very short. 0.02. What is the difference between the highest and the second highest Cost (as % of GNI) in Water?
Your answer should be compact. 6.93. What is the difference between the highest and the lowest Cost (as % of GNI) of Coal?
Ensure brevity in your answer.  1.16. What is the difference between the highest and the lowest Cost (as % of GNI) of Minerals?
Offer a very short reply. 0.2. What is the difference between the highest and the lowest Cost (as % of GNI) of Energy?
Offer a terse response. 12.14. What is the difference between the highest and the lowest Cost (as % of GNI) in Water?
Make the answer very short. 12.48. 